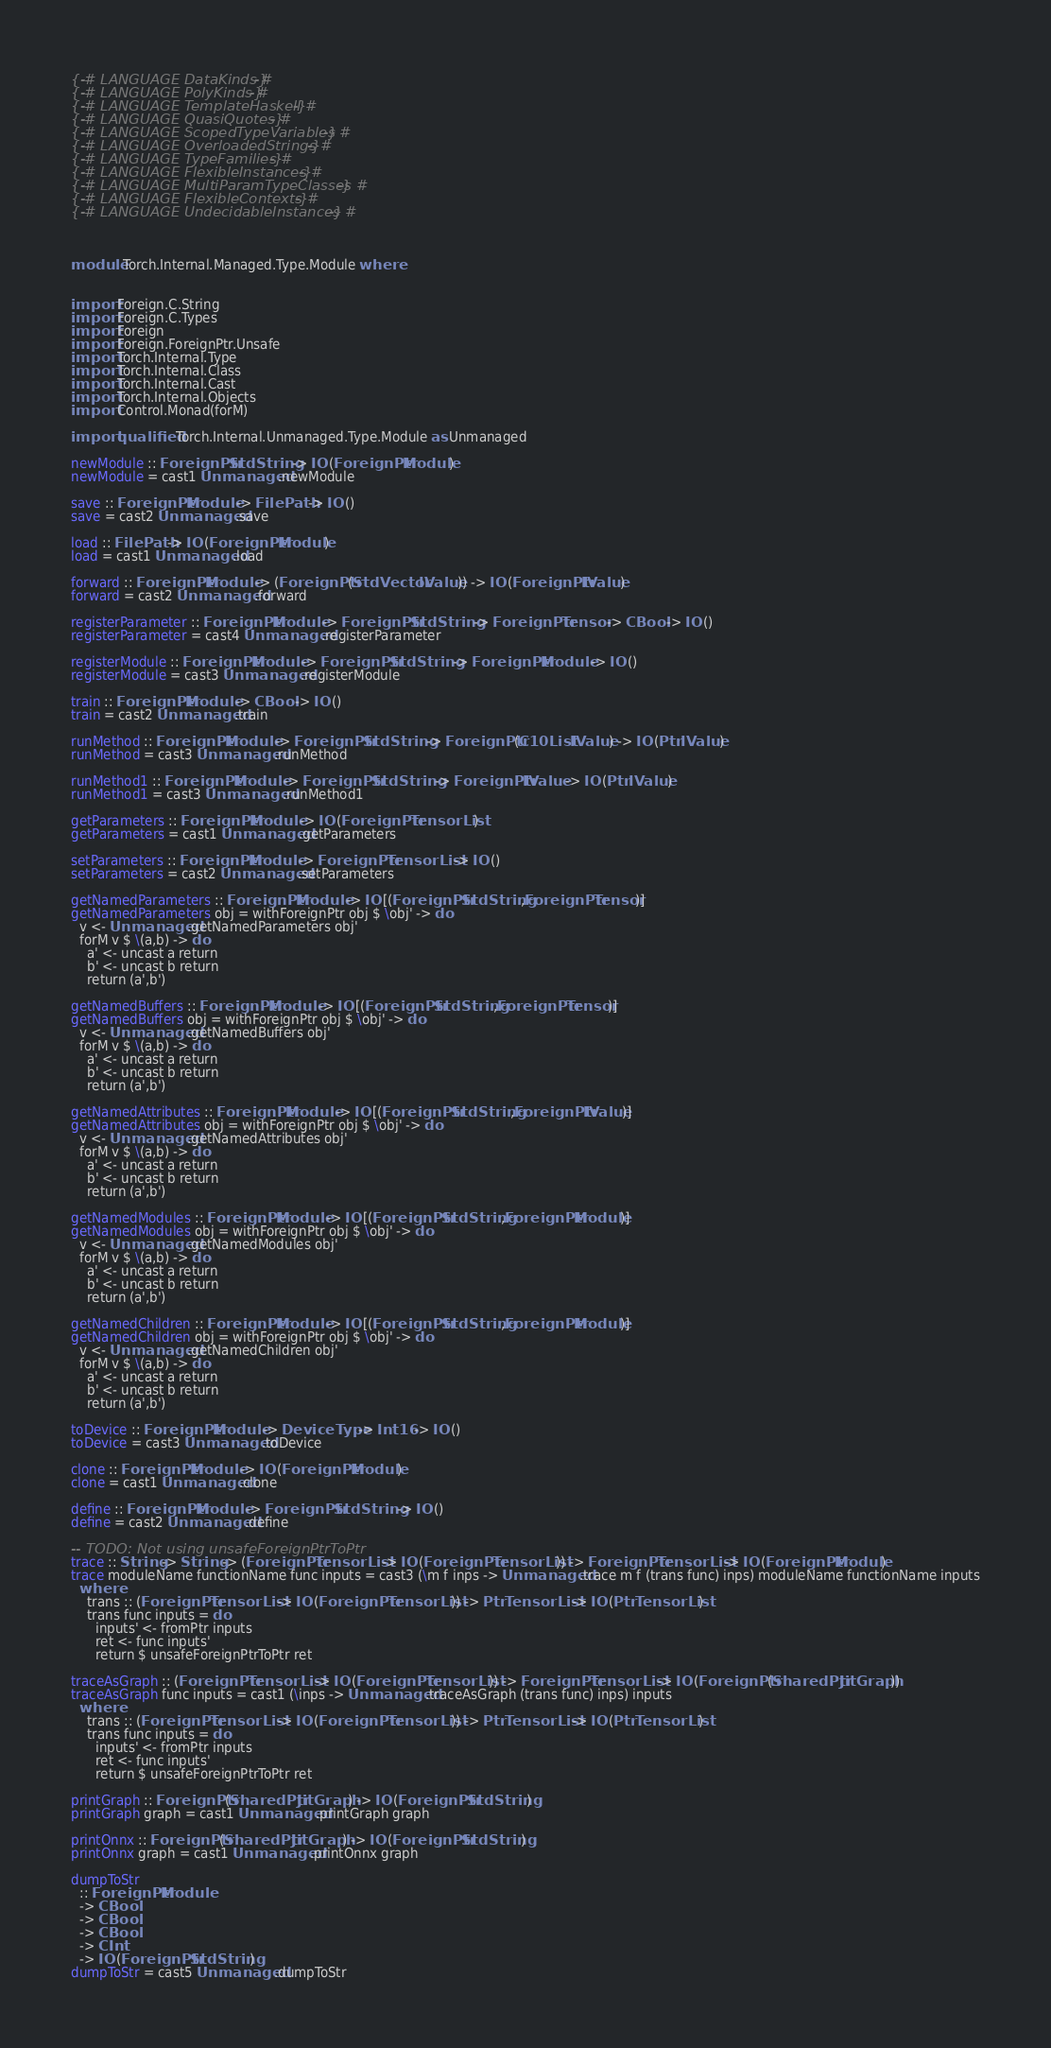<code> <loc_0><loc_0><loc_500><loc_500><_Haskell_>
{-# LANGUAGE DataKinds #-}
{-# LANGUAGE PolyKinds #-}
{-# LANGUAGE TemplateHaskell #-}
{-# LANGUAGE QuasiQuotes #-}
{-# LANGUAGE ScopedTypeVariables #-}
{-# LANGUAGE OverloadedStrings #-}
{-# LANGUAGE TypeFamilies #-}
{-# LANGUAGE FlexibleInstances #-}
{-# LANGUAGE MultiParamTypeClasses #-}
{-# LANGUAGE FlexibleContexts #-}
{-# LANGUAGE UndecidableInstances #-}



module Torch.Internal.Managed.Type.Module where


import Foreign.C.String
import Foreign.C.Types
import Foreign
import Foreign.ForeignPtr.Unsafe
import Torch.Internal.Type
import Torch.Internal.Class
import Torch.Internal.Cast
import Torch.Internal.Objects
import Control.Monad(forM)

import qualified Torch.Internal.Unmanaged.Type.Module as Unmanaged

newModule :: ForeignPtr StdString -> IO (ForeignPtr Module)
newModule = cast1 Unmanaged.newModule

save :: ForeignPtr Module -> FilePath -> IO ()
save = cast2 Unmanaged.save

load :: FilePath -> IO (ForeignPtr Module)
load = cast1 Unmanaged.load

forward :: ForeignPtr Module -> (ForeignPtr (StdVector IValue)) -> IO (ForeignPtr IValue)
forward = cast2 Unmanaged.forward

registerParameter :: ForeignPtr Module -> ForeignPtr StdString -> ForeignPtr Tensor -> CBool -> IO ()
registerParameter = cast4 Unmanaged.registerParameter

registerModule :: ForeignPtr Module -> ForeignPtr StdString -> ForeignPtr Module -> IO ()
registerModule = cast3 Unmanaged.registerModule

train :: ForeignPtr Module -> CBool -> IO ()
train = cast2 Unmanaged.train

runMethod :: ForeignPtr Module -> ForeignPtr StdString -> ForeignPtr (C10List IValue) -> IO (Ptr IValue)
runMethod = cast3 Unmanaged.runMethod

runMethod1 :: ForeignPtr Module -> ForeignPtr StdString -> ForeignPtr IValue -> IO (Ptr IValue)
runMethod1 = cast3 Unmanaged.runMethod1

getParameters :: ForeignPtr Module -> IO (ForeignPtr TensorList)
getParameters = cast1 Unmanaged.getParameters

setParameters :: ForeignPtr Module -> ForeignPtr TensorList -> IO ()
setParameters = cast2 Unmanaged.setParameters

getNamedParameters :: ForeignPtr Module -> IO [(ForeignPtr StdString,ForeignPtr Tensor)]
getNamedParameters obj = withForeignPtr obj $ \obj' -> do
  v <- Unmanaged.getNamedParameters obj'
  forM v $ \(a,b) -> do
    a' <- uncast a return 
    b' <- uncast b return
    return (a',b')

getNamedBuffers :: ForeignPtr Module -> IO [(ForeignPtr StdString,ForeignPtr Tensor)]
getNamedBuffers obj = withForeignPtr obj $ \obj' -> do
  v <- Unmanaged.getNamedBuffers obj'
  forM v $ \(a,b) -> do
    a' <- uncast a return 
    b' <- uncast b return
    return (a',b')

getNamedAttributes :: ForeignPtr Module -> IO [(ForeignPtr StdString,ForeignPtr IValue)]
getNamedAttributes obj = withForeignPtr obj $ \obj' -> do
  v <- Unmanaged.getNamedAttributes obj'
  forM v $ \(a,b) -> do
    a' <- uncast a return 
    b' <- uncast b return
    return (a',b')

getNamedModules :: ForeignPtr Module -> IO [(ForeignPtr StdString,ForeignPtr Module)]
getNamedModules obj = withForeignPtr obj $ \obj' -> do
  v <- Unmanaged.getNamedModules obj'
  forM v $ \(a,b) -> do
    a' <- uncast a return 
    b' <- uncast b return
    return (a',b')

getNamedChildren :: ForeignPtr Module -> IO [(ForeignPtr StdString,ForeignPtr Module)]
getNamedChildren obj = withForeignPtr obj $ \obj' -> do
  v <- Unmanaged.getNamedChildren obj'
  forM v $ \(a,b) -> do
    a' <- uncast a return 
    b' <- uncast b return
    return (a',b')

toDevice :: ForeignPtr Module -> DeviceType -> Int16 -> IO ()
toDevice = cast3 Unmanaged.toDevice

clone :: ForeignPtr Module -> IO (ForeignPtr Module)
clone = cast1 Unmanaged.clone

define :: ForeignPtr Module -> ForeignPtr StdString -> IO ()
define = cast2 Unmanaged.define

-- TODO: Not using unsafeForeignPtrToPtr
trace :: String -> String -> (ForeignPtr TensorList -> IO (ForeignPtr TensorList)) -> ForeignPtr TensorList -> IO (ForeignPtr Module)
trace moduleName functionName func inputs = cast3 (\m f inps -> Unmanaged.trace m f (trans func) inps) moduleName functionName inputs
  where
    trans :: (ForeignPtr TensorList -> IO (ForeignPtr TensorList)) -> Ptr TensorList -> IO (Ptr TensorList)
    trans func inputs = do
      inputs' <- fromPtr inputs
      ret <- func inputs'
      return $ unsafeForeignPtrToPtr ret

traceAsGraph :: (ForeignPtr TensorList -> IO (ForeignPtr TensorList)) -> ForeignPtr TensorList -> IO (ForeignPtr (SharedPtr JitGraph))
traceAsGraph func inputs = cast1 (\inps -> Unmanaged.traceAsGraph (trans func) inps) inputs
  where
    trans :: (ForeignPtr TensorList -> IO (ForeignPtr TensorList)) -> Ptr TensorList -> IO (Ptr TensorList)
    trans func inputs = do
      inputs' <- fromPtr inputs
      ret <- func inputs'
      return $ unsafeForeignPtrToPtr ret

printGraph :: ForeignPtr (SharedPtr JitGraph) -> IO (ForeignPtr StdString)
printGraph graph = cast1 Unmanaged.printGraph graph

printOnnx :: ForeignPtr (SharedPtr JitGraph) -> IO (ForeignPtr StdString)
printOnnx graph = cast1 Unmanaged.printOnnx graph

dumpToStr
  :: ForeignPtr Module
  -> CBool
  -> CBool
  -> CBool
  -> CInt
  -> IO (ForeignPtr StdString)
dumpToStr = cast5 Unmanaged.dumpToStr
</code> 